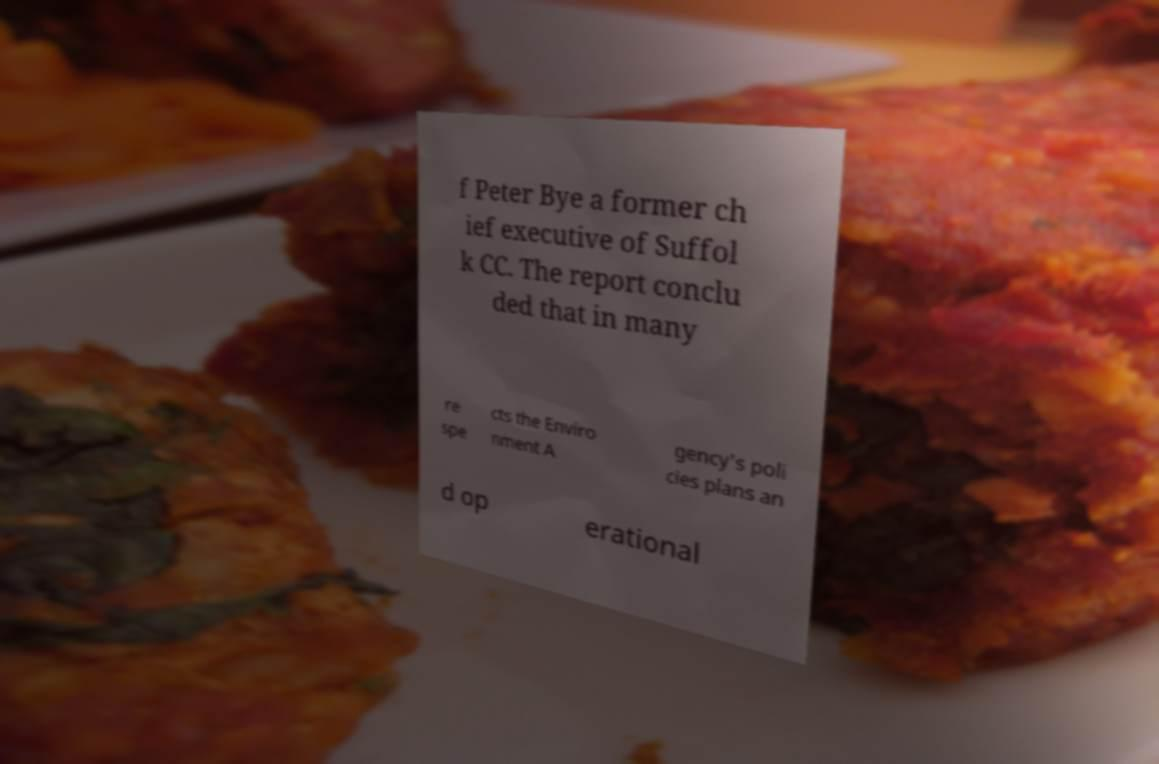Please read and relay the text visible in this image. What does it say? f Peter Bye a former ch ief executive of Suffol k CC. The report conclu ded that in many re spe cts the Enviro nment A gency's poli cies plans an d op erational 